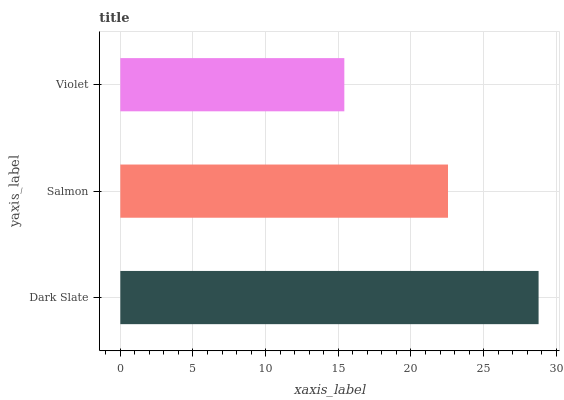Is Violet the minimum?
Answer yes or no. Yes. Is Dark Slate the maximum?
Answer yes or no. Yes. Is Salmon the minimum?
Answer yes or no. No. Is Salmon the maximum?
Answer yes or no. No. Is Dark Slate greater than Salmon?
Answer yes or no. Yes. Is Salmon less than Dark Slate?
Answer yes or no. Yes. Is Salmon greater than Dark Slate?
Answer yes or no. No. Is Dark Slate less than Salmon?
Answer yes or no. No. Is Salmon the high median?
Answer yes or no. Yes. Is Salmon the low median?
Answer yes or no. Yes. Is Dark Slate the high median?
Answer yes or no. No. Is Violet the low median?
Answer yes or no. No. 